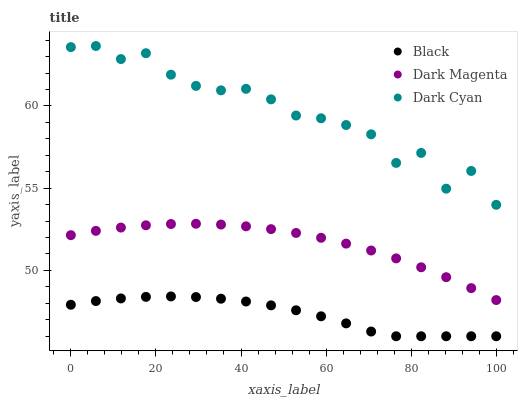Does Black have the minimum area under the curve?
Answer yes or no. Yes. Does Dark Cyan have the maximum area under the curve?
Answer yes or no. Yes. Does Dark Magenta have the minimum area under the curve?
Answer yes or no. No. Does Dark Magenta have the maximum area under the curve?
Answer yes or no. No. Is Dark Magenta the smoothest?
Answer yes or no. Yes. Is Dark Cyan the roughest?
Answer yes or no. Yes. Is Black the smoothest?
Answer yes or no. No. Is Black the roughest?
Answer yes or no. No. Does Black have the lowest value?
Answer yes or no. Yes. Does Dark Magenta have the lowest value?
Answer yes or no. No. Does Dark Cyan have the highest value?
Answer yes or no. Yes. Does Dark Magenta have the highest value?
Answer yes or no. No. Is Black less than Dark Magenta?
Answer yes or no. Yes. Is Dark Cyan greater than Black?
Answer yes or no. Yes. Does Black intersect Dark Magenta?
Answer yes or no. No. 